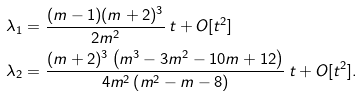Convert formula to latex. <formula><loc_0><loc_0><loc_500><loc_500>\lambda _ { 1 } & = \frac { ( m - 1 ) ( m + 2 ) ^ { 3 } } { 2 m ^ { 2 } } \, t + O [ t ^ { 2 } ] \\ \lambda _ { 2 } & = \frac { ( m + 2 ) ^ { 3 } \left ( m ^ { 3 } - 3 m ^ { 2 } - 1 0 m + 1 2 \right ) } { 4 m ^ { 2 } \left ( m ^ { 2 } - m - 8 \right ) } \, t + O [ t ^ { 2 } ] .</formula> 